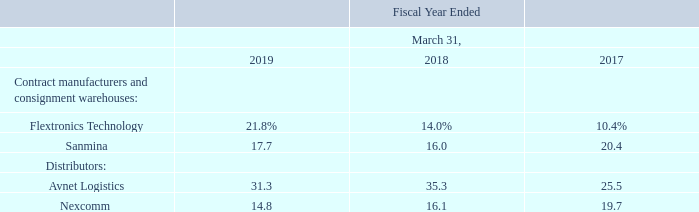The following direct customers accounted for 10% or more of our net revenues in one or more of the following periods:
Nokia was our largest customer in fiscal 2019, 2018 and 2017. Nokia purchases products directly from us and through contract manufacturers and distributors. Based on information provided to us by its contract manufacturers and our distributors, purchases by Nokia represented approximately 45%, 36% and 41% of our net revenues in fiscal 2019, 2018 and 2017, respectively. To our knowledge, none of our other OEM customers accounted for more than 10% of our net revenues in any of these periods.
Who was the largest customer in 2019, 2018 and 2017? Nokia. What was the percentage of purchases made by Nokia in 2019, 2018 and 2017 respectively? 45%, 36%, 41%. What was the percentage from Flextronics Technology in 2019?
Answer scale should be: percent. 21.8. In which year was Flextronics Technology less than 20.0%? Locate and analyze flextronics technology in row 5
answer: 2018, 2017. What was the change in net revenue from Sanmina from 2018 to 2019?
Answer scale should be: percent. 17.7 - 16.0
Answer: 1.7. What was the average revenues from Avnet Logistics between 2017-2019?
Answer scale should be: percent. (31.3 + 35.3 + 25.5) / 3
Answer: 30.7. 